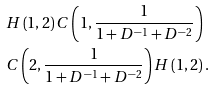Convert formula to latex. <formula><loc_0><loc_0><loc_500><loc_500>& H \left ( 1 , 2 \right ) C \left ( 1 , \frac { 1 } { 1 + D ^ { - 1 } + D ^ { - 2 } } \right ) \\ & C \left ( 2 , \frac { 1 } { 1 + D ^ { - 1 } + D ^ { - 2 } } \right ) H \left ( 1 , 2 \right ) .</formula> 